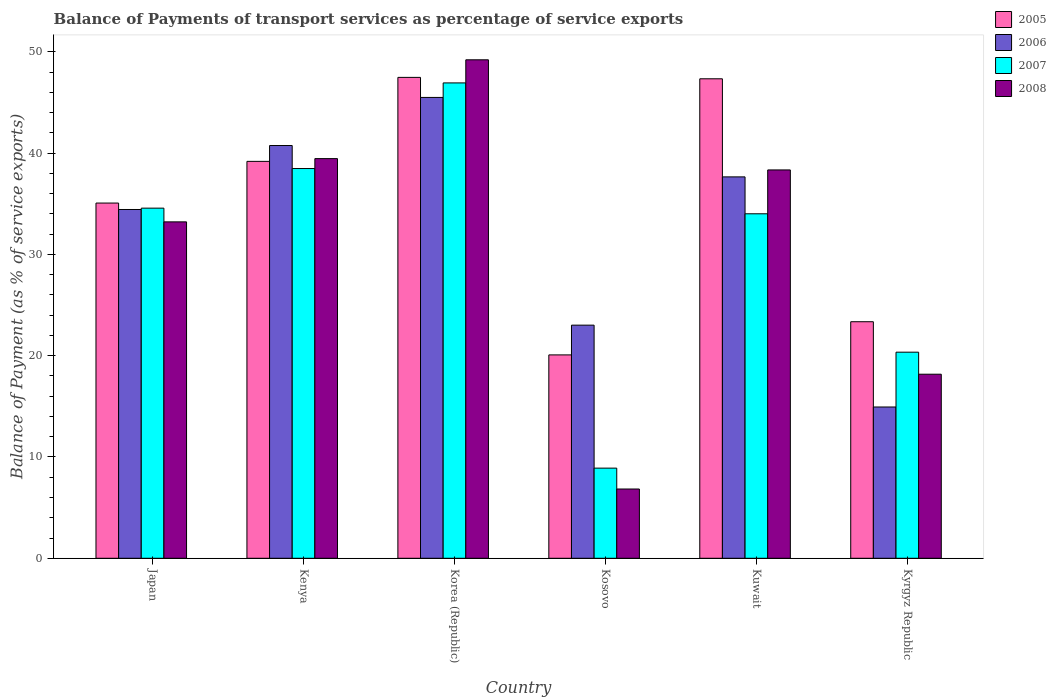How many different coloured bars are there?
Offer a very short reply. 4. How many groups of bars are there?
Offer a terse response. 6. How many bars are there on the 5th tick from the left?
Your answer should be very brief. 4. What is the label of the 3rd group of bars from the left?
Make the answer very short. Korea (Republic). What is the balance of payments of transport services in 2005 in Kenya?
Provide a short and direct response. 39.18. Across all countries, what is the maximum balance of payments of transport services in 2006?
Provide a short and direct response. 45.49. Across all countries, what is the minimum balance of payments of transport services in 2006?
Your answer should be very brief. 14.93. In which country was the balance of payments of transport services in 2005 maximum?
Provide a succinct answer. Korea (Republic). In which country was the balance of payments of transport services in 2006 minimum?
Make the answer very short. Kyrgyz Republic. What is the total balance of payments of transport services in 2006 in the graph?
Your response must be concise. 196.26. What is the difference between the balance of payments of transport services in 2006 in Kosovo and that in Kuwait?
Ensure brevity in your answer.  -14.64. What is the difference between the balance of payments of transport services in 2005 in Kenya and the balance of payments of transport services in 2008 in Korea (Republic)?
Give a very brief answer. -10.03. What is the average balance of payments of transport services in 2006 per country?
Give a very brief answer. 32.71. What is the difference between the balance of payments of transport services of/in 2008 and balance of payments of transport services of/in 2006 in Kosovo?
Your answer should be compact. -16.18. In how many countries, is the balance of payments of transport services in 2006 greater than 8 %?
Your response must be concise. 6. What is the ratio of the balance of payments of transport services in 2005 in Kenya to that in Kyrgyz Republic?
Keep it short and to the point. 1.68. Is the balance of payments of transport services in 2006 in Korea (Republic) less than that in Kosovo?
Keep it short and to the point. No. Is the difference between the balance of payments of transport services in 2008 in Kenya and Kyrgyz Republic greater than the difference between the balance of payments of transport services in 2006 in Kenya and Kyrgyz Republic?
Your answer should be very brief. No. What is the difference between the highest and the second highest balance of payments of transport services in 2005?
Your answer should be compact. -8.15. What is the difference between the highest and the lowest balance of payments of transport services in 2005?
Offer a terse response. 27.4. Is the sum of the balance of payments of transport services in 2005 in Japan and Korea (Republic) greater than the maximum balance of payments of transport services in 2008 across all countries?
Give a very brief answer. Yes. What does the 3rd bar from the left in Japan represents?
Your answer should be compact. 2007. Is it the case that in every country, the sum of the balance of payments of transport services in 2006 and balance of payments of transport services in 2008 is greater than the balance of payments of transport services in 2007?
Your answer should be compact. Yes. Are all the bars in the graph horizontal?
Keep it short and to the point. No. What is the difference between two consecutive major ticks on the Y-axis?
Provide a succinct answer. 10. Are the values on the major ticks of Y-axis written in scientific E-notation?
Ensure brevity in your answer.  No. Does the graph contain grids?
Provide a succinct answer. No. What is the title of the graph?
Offer a very short reply. Balance of Payments of transport services as percentage of service exports. What is the label or title of the Y-axis?
Offer a terse response. Balance of Payment (as % of service exports). What is the Balance of Payment (as % of service exports) of 2005 in Japan?
Provide a succinct answer. 35.06. What is the Balance of Payment (as % of service exports) of 2006 in Japan?
Provide a succinct answer. 34.43. What is the Balance of Payment (as % of service exports) of 2007 in Japan?
Offer a terse response. 34.56. What is the Balance of Payment (as % of service exports) in 2008 in Japan?
Your answer should be compact. 33.21. What is the Balance of Payment (as % of service exports) of 2005 in Kenya?
Your response must be concise. 39.18. What is the Balance of Payment (as % of service exports) of 2006 in Kenya?
Your response must be concise. 40.74. What is the Balance of Payment (as % of service exports) of 2007 in Kenya?
Offer a very short reply. 38.47. What is the Balance of Payment (as % of service exports) of 2008 in Kenya?
Give a very brief answer. 39.45. What is the Balance of Payment (as % of service exports) of 2005 in Korea (Republic)?
Provide a succinct answer. 47.47. What is the Balance of Payment (as % of service exports) of 2006 in Korea (Republic)?
Your answer should be very brief. 45.49. What is the Balance of Payment (as % of service exports) in 2007 in Korea (Republic)?
Provide a short and direct response. 46.92. What is the Balance of Payment (as % of service exports) of 2008 in Korea (Republic)?
Provide a succinct answer. 49.21. What is the Balance of Payment (as % of service exports) in 2005 in Kosovo?
Make the answer very short. 20.08. What is the Balance of Payment (as % of service exports) in 2006 in Kosovo?
Your answer should be very brief. 23.01. What is the Balance of Payment (as % of service exports) in 2007 in Kosovo?
Your answer should be very brief. 8.9. What is the Balance of Payment (as % of service exports) in 2008 in Kosovo?
Your answer should be very brief. 6.84. What is the Balance of Payment (as % of service exports) in 2005 in Kuwait?
Provide a short and direct response. 47.33. What is the Balance of Payment (as % of service exports) of 2006 in Kuwait?
Offer a terse response. 37.65. What is the Balance of Payment (as % of service exports) in 2007 in Kuwait?
Your response must be concise. 34.01. What is the Balance of Payment (as % of service exports) in 2008 in Kuwait?
Provide a succinct answer. 38.33. What is the Balance of Payment (as % of service exports) of 2005 in Kyrgyz Republic?
Provide a short and direct response. 23.35. What is the Balance of Payment (as % of service exports) in 2006 in Kyrgyz Republic?
Your answer should be very brief. 14.93. What is the Balance of Payment (as % of service exports) in 2007 in Kyrgyz Republic?
Your answer should be very brief. 20.34. What is the Balance of Payment (as % of service exports) in 2008 in Kyrgyz Republic?
Your answer should be compact. 18.17. Across all countries, what is the maximum Balance of Payment (as % of service exports) of 2005?
Your response must be concise. 47.47. Across all countries, what is the maximum Balance of Payment (as % of service exports) of 2006?
Offer a very short reply. 45.49. Across all countries, what is the maximum Balance of Payment (as % of service exports) of 2007?
Your answer should be very brief. 46.92. Across all countries, what is the maximum Balance of Payment (as % of service exports) in 2008?
Your response must be concise. 49.21. Across all countries, what is the minimum Balance of Payment (as % of service exports) of 2005?
Provide a short and direct response. 20.08. Across all countries, what is the minimum Balance of Payment (as % of service exports) of 2006?
Your response must be concise. 14.93. Across all countries, what is the minimum Balance of Payment (as % of service exports) in 2007?
Offer a terse response. 8.9. Across all countries, what is the minimum Balance of Payment (as % of service exports) of 2008?
Ensure brevity in your answer.  6.84. What is the total Balance of Payment (as % of service exports) of 2005 in the graph?
Make the answer very short. 212.47. What is the total Balance of Payment (as % of service exports) of 2006 in the graph?
Ensure brevity in your answer.  196.26. What is the total Balance of Payment (as % of service exports) of 2007 in the graph?
Ensure brevity in your answer.  183.21. What is the total Balance of Payment (as % of service exports) of 2008 in the graph?
Ensure brevity in your answer.  185.21. What is the difference between the Balance of Payment (as % of service exports) in 2005 in Japan and that in Kenya?
Ensure brevity in your answer.  -4.12. What is the difference between the Balance of Payment (as % of service exports) in 2006 in Japan and that in Kenya?
Keep it short and to the point. -6.31. What is the difference between the Balance of Payment (as % of service exports) of 2007 in Japan and that in Kenya?
Your response must be concise. -3.91. What is the difference between the Balance of Payment (as % of service exports) of 2008 in Japan and that in Kenya?
Offer a terse response. -6.24. What is the difference between the Balance of Payment (as % of service exports) of 2005 in Japan and that in Korea (Republic)?
Keep it short and to the point. -12.41. What is the difference between the Balance of Payment (as % of service exports) of 2006 in Japan and that in Korea (Republic)?
Make the answer very short. -11.06. What is the difference between the Balance of Payment (as % of service exports) of 2007 in Japan and that in Korea (Republic)?
Give a very brief answer. -12.36. What is the difference between the Balance of Payment (as % of service exports) of 2008 in Japan and that in Korea (Republic)?
Your answer should be very brief. -16. What is the difference between the Balance of Payment (as % of service exports) of 2005 in Japan and that in Kosovo?
Offer a terse response. 14.99. What is the difference between the Balance of Payment (as % of service exports) in 2006 in Japan and that in Kosovo?
Offer a terse response. 11.42. What is the difference between the Balance of Payment (as % of service exports) of 2007 in Japan and that in Kosovo?
Offer a terse response. 25.66. What is the difference between the Balance of Payment (as % of service exports) of 2008 in Japan and that in Kosovo?
Give a very brief answer. 26.37. What is the difference between the Balance of Payment (as % of service exports) in 2005 in Japan and that in Kuwait?
Your answer should be compact. -12.27. What is the difference between the Balance of Payment (as % of service exports) in 2006 in Japan and that in Kuwait?
Offer a terse response. -3.22. What is the difference between the Balance of Payment (as % of service exports) in 2007 in Japan and that in Kuwait?
Ensure brevity in your answer.  0.56. What is the difference between the Balance of Payment (as % of service exports) of 2008 in Japan and that in Kuwait?
Offer a terse response. -5.13. What is the difference between the Balance of Payment (as % of service exports) in 2005 in Japan and that in Kyrgyz Republic?
Your answer should be very brief. 11.71. What is the difference between the Balance of Payment (as % of service exports) in 2006 in Japan and that in Kyrgyz Republic?
Keep it short and to the point. 19.5. What is the difference between the Balance of Payment (as % of service exports) in 2007 in Japan and that in Kyrgyz Republic?
Give a very brief answer. 14.22. What is the difference between the Balance of Payment (as % of service exports) in 2008 in Japan and that in Kyrgyz Republic?
Your answer should be very brief. 15.04. What is the difference between the Balance of Payment (as % of service exports) of 2005 in Kenya and that in Korea (Republic)?
Your response must be concise. -8.29. What is the difference between the Balance of Payment (as % of service exports) of 2006 in Kenya and that in Korea (Republic)?
Your answer should be very brief. -4.75. What is the difference between the Balance of Payment (as % of service exports) in 2007 in Kenya and that in Korea (Republic)?
Your answer should be compact. -8.45. What is the difference between the Balance of Payment (as % of service exports) of 2008 in Kenya and that in Korea (Republic)?
Keep it short and to the point. -9.75. What is the difference between the Balance of Payment (as % of service exports) of 2005 in Kenya and that in Kosovo?
Keep it short and to the point. 19.1. What is the difference between the Balance of Payment (as % of service exports) of 2006 in Kenya and that in Kosovo?
Offer a very short reply. 17.73. What is the difference between the Balance of Payment (as % of service exports) in 2007 in Kenya and that in Kosovo?
Provide a short and direct response. 29.57. What is the difference between the Balance of Payment (as % of service exports) of 2008 in Kenya and that in Kosovo?
Provide a short and direct response. 32.62. What is the difference between the Balance of Payment (as % of service exports) in 2005 in Kenya and that in Kuwait?
Keep it short and to the point. -8.15. What is the difference between the Balance of Payment (as % of service exports) of 2006 in Kenya and that in Kuwait?
Keep it short and to the point. 3.1. What is the difference between the Balance of Payment (as % of service exports) in 2007 in Kenya and that in Kuwait?
Your answer should be very brief. 4.47. What is the difference between the Balance of Payment (as % of service exports) in 2008 in Kenya and that in Kuwait?
Make the answer very short. 1.12. What is the difference between the Balance of Payment (as % of service exports) of 2005 in Kenya and that in Kyrgyz Republic?
Provide a succinct answer. 15.83. What is the difference between the Balance of Payment (as % of service exports) of 2006 in Kenya and that in Kyrgyz Republic?
Provide a succinct answer. 25.81. What is the difference between the Balance of Payment (as % of service exports) of 2007 in Kenya and that in Kyrgyz Republic?
Offer a very short reply. 18.13. What is the difference between the Balance of Payment (as % of service exports) in 2008 in Kenya and that in Kyrgyz Republic?
Keep it short and to the point. 21.28. What is the difference between the Balance of Payment (as % of service exports) in 2005 in Korea (Republic) and that in Kosovo?
Your answer should be compact. 27.4. What is the difference between the Balance of Payment (as % of service exports) of 2006 in Korea (Republic) and that in Kosovo?
Your answer should be very brief. 22.48. What is the difference between the Balance of Payment (as % of service exports) in 2007 in Korea (Republic) and that in Kosovo?
Your answer should be very brief. 38.03. What is the difference between the Balance of Payment (as % of service exports) of 2008 in Korea (Republic) and that in Kosovo?
Offer a terse response. 42.37. What is the difference between the Balance of Payment (as % of service exports) in 2005 in Korea (Republic) and that in Kuwait?
Provide a succinct answer. 0.14. What is the difference between the Balance of Payment (as % of service exports) of 2006 in Korea (Republic) and that in Kuwait?
Your answer should be very brief. 7.84. What is the difference between the Balance of Payment (as % of service exports) in 2007 in Korea (Republic) and that in Kuwait?
Your answer should be compact. 12.92. What is the difference between the Balance of Payment (as % of service exports) of 2008 in Korea (Republic) and that in Kuwait?
Your response must be concise. 10.87. What is the difference between the Balance of Payment (as % of service exports) in 2005 in Korea (Republic) and that in Kyrgyz Republic?
Make the answer very short. 24.12. What is the difference between the Balance of Payment (as % of service exports) in 2006 in Korea (Republic) and that in Kyrgyz Republic?
Offer a very short reply. 30.56. What is the difference between the Balance of Payment (as % of service exports) of 2007 in Korea (Republic) and that in Kyrgyz Republic?
Your response must be concise. 26.58. What is the difference between the Balance of Payment (as % of service exports) of 2008 in Korea (Republic) and that in Kyrgyz Republic?
Your answer should be compact. 31.04. What is the difference between the Balance of Payment (as % of service exports) of 2005 in Kosovo and that in Kuwait?
Give a very brief answer. -27.26. What is the difference between the Balance of Payment (as % of service exports) of 2006 in Kosovo and that in Kuwait?
Keep it short and to the point. -14.64. What is the difference between the Balance of Payment (as % of service exports) in 2007 in Kosovo and that in Kuwait?
Offer a terse response. -25.11. What is the difference between the Balance of Payment (as % of service exports) in 2008 in Kosovo and that in Kuwait?
Keep it short and to the point. -31.5. What is the difference between the Balance of Payment (as % of service exports) of 2005 in Kosovo and that in Kyrgyz Republic?
Your answer should be compact. -3.27. What is the difference between the Balance of Payment (as % of service exports) of 2006 in Kosovo and that in Kyrgyz Republic?
Provide a short and direct response. 8.08. What is the difference between the Balance of Payment (as % of service exports) in 2007 in Kosovo and that in Kyrgyz Republic?
Provide a short and direct response. -11.45. What is the difference between the Balance of Payment (as % of service exports) of 2008 in Kosovo and that in Kyrgyz Republic?
Make the answer very short. -11.33. What is the difference between the Balance of Payment (as % of service exports) in 2005 in Kuwait and that in Kyrgyz Republic?
Provide a succinct answer. 23.98. What is the difference between the Balance of Payment (as % of service exports) in 2006 in Kuwait and that in Kyrgyz Republic?
Your response must be concise. 22.72. What is the difference between the Balance of Payment (as % of service exports) of 2007 in Kuwait and that in Kyrgyz Republic?
Provide a short and direct response. 13.66. What is the difference between the Balance of Payment (as % of service exports) in 2008 in Kuwait and that in Kyrgyz Republic?
Give a very brief answer. 20.17. What is the difference between the Balance of Payment (as % of service exports) of 2005 in Japan and the Balance of Payment (as % of service exports) of 2006 in Kenya?
Ensure brevity in your answer.  -5.68. What is the difference between the Balance of Payment (as % of service exports) in 2005 in Japan and the Balance of Payment (as % of service exports) in 2007 in Kenya?
Give a very brief answer. -3.41. What is the difference between the Balance of Payment (as % of service exports) of 2005 in Japan and the Balance of Payment (as % of service exports) of 2008 in Kenya?
Keep it short and to the point. -4.39. What is the difference between the Balance of Payment (as % of service exports) in 2006 in Japan and the Balance of Payment (as % of service exports) in 2007 in Kenya?
Your response must be concise. -4.04. What is the difference between the Balance of Payment (as % of service exports) of 2006 in Japan and the Balance of Payment (as % of service exports) of 2008 in Kenya?
Your response must be concise. -5.02. What is the difference between the Balance of Payment (as % of service exports) of 2007 in Japan and the Balance of Payment (as % of service exports) of 2008 in Kenya?
Your answer should be very brief. -4.89. What is the difference between the Balance of Payment (as % of service exports) of 2005 in Japan and the Balance of Payment (as % of service exports) of 2006 in Korea (Republic)?
Offer a terse response. -10.43. What is the difference between the Balance of Payment (as % of service exports) of 2005 in Japan and the Balance of Payment (as % of service exports) of 2007 in Korea (Republic)?
Your answer should be compact. -11.86. What is the difference between the Balance of Payment (as % of service exports) of 2005 in Japan and the Balance of Payment (as % of service exports) of 2008 in Korea (Republic)?
Give a very brief answer. -14.14. What is the difference between the Balance of Payment (as % of service exports) in 2006 in Japan and the Balance of Payment (as % of service exports) in 2007 in Korea (Republic)?
Your answer should be compact. -12.49. What is the difference between the Balance of Payment (as % of service exports) in 2006 in Japan and the Balance of Payment (as % of service exports) in 2008 in Korea (Republic)?
Offer a very short reply. -14.78. What is the difference between the Balance of Payment (as % of service exports) in 2007 in Japan and the Balance of Payment (as % of service exports) in 2008 in Korea (Republic)?
Your response must be concise. -14.64. What is the difference between the Balance of Payment (as % of service exports) of 2005 in Japan and the Balance of Payment (as % of service exports) of 2006 in Kosovo?
Ensure brevity in your answer.  12.05. What is the difference between the Balance of Payment (as % of service exports) in 2005 in Japan and the Balance of Payment (as % of service exports) in 2007 in Kosovo?
Keep it short and to the point. 26.17. What is the difference between the Balance of Payment (as % of service exports) of 2005 in Japan and the Balance of Payment (as % of service exports) of 2008 in Kosovo?
Your response must be concise. 28.23. What is the difference between the Balance of Payment (as % of service exports) of 2006 in Japan and the Balance of Payment (as % of service exports) of 2007 in Kosovo?
Make the answer very short. 25.53. What is the difference between the Balance of Payment (as % of service exports) of 2006 in Japan and the Balance of Payment (as % of service exports) of 2008 in Kosovo?
Make the answer very short. 27.59. What is the difference between the Balance of Payment (as % of service exports) of 2007 in Japan and the Balance of Payment (as % of service exports) of 2008 in Kosovo?
Offer a very short reply. 27.73. What is the difference between the Balance of Payment (as % of service exports) of 2005 in Japan and the Balance of Payment (as % of service exports) of 2006 in Kuwait?
Make the answer very short. -2.58. What is the difference between the Balance of Payment (as % of service exports) in 2005 in Japan and the Balance of Payment (as % of service exports) in 2007 in Kuwait?
Make the answer very short. 1.06. What is the difference between the Balance of Payment (as % of service exports) of 2005 in Japan and the Balance of Payment (as % of service exports) of 2008 in Kuwait?
Ensure brevity in your answer.  -3.27. What is the difference between the Balance of Payment (as % of service exports) in 2006 in Japan and the Balance of Payment (as % of service exports) in 2007 in Kuwait?
Make the answer very short. 0.42. What is the difference between the Balance of Payment (as % of service exports) in 2006 in Japan and the Balance of Payment (as % of service exports) in 2008 in Kuwait?
Offer a terse response. -3.9. What is the difference between the Balance of Payment (as % of service exports) in 2007 in Japan and the Balance of Payment (as % of service exports) in 2008 in Kuwait?
Provide a short and direct response. -3.77. What is the difference between the Balance of Payment (as % of service exports) in 2005 in Japan and the Balance of Payment (as % of service exports) in 2006 in Kyrgyz Republic?
Give a very brief answer. 20.13. What is the difference between the Balance of Payment (as % of service exports) of 2005 in Japan and the Balance of Payment (as % of service exports) of 2007 in Kyrgyz Republic?
Keep it short and to the point. 14.72. What is the difference between the Balance of Payment (as % of service exports) in 2005 in Japan and the Balance of Payment (as % of service exports) in 2008 in Kyrgyz Republic?
Offer a very short reply. 16.9. What is the difference between the Balance of Payment (as % of service exports) in 2006 in Japan and the Balance of Payment (as % of service exports) in 2007 in Kyrgyz Republic?
Make the answer very short. 14.09. What is the difference between the Balance of Payment (as % of service exports) of 2006 in Japan and the Balance of Payment (as % of service exports) of 2008 in Kyrgyz Republic?
Your answer should be very brief. 16.26. What is the difference between the Balance of Payment (as % of service exports) of 2007 in Japan and the Balance of Payment (as % of service exports) of 2008 in Kyrgyz Republic?
Your answer should be compact. 16.39. What is the difference between the Balance of Payment (as % of service exports) in 2005 in Kenya and the Balance of Payment (as % of service exports) in 2006 in Korea (Republic)?
Offer a terse response. -6.31. What is the difference between the Balance of Payment (as % of service exports) in 2005 in Kenya and the Balance of Payment (as % of service exports) in 2007 in Korea (Republic)?
Provide a short and direct response. -7.74. What is the difference between the Balance of Payment (as % of service exports) of 2005 in Kenya and the Balance of Payment (as % of service exports) of 2008 in Korea (Republic)?
Your response must be concise. -10.03. What is the difference between the Balance of Payment (as % of service exports) in 2006 in Kenya and the Balance of Payment (as % of service exports) in 2007 in Korea (Republic)?
Your response must be concise. -6.18. What is the difference between the Balance of Payment (as % of service exports) in 2006 in Kenya and the Balance of Payment (as % of service exports) in 2008 in Korea (Republic)?
Your response must be concise. -8.46. What is the difference between the Balance of Payment (as % of service exports) of 2007 in Kenya and the Balance of Payment (as % of service exports) of 2008 in Korea (Republic)?
Give a very brief answer. -10.73. What is the difference between the Balance of Payment (as % of service exports) of 2005 in Kenya and the Balance of Payment (as % of service exports) of 2006 in Kosovo?
Provide a short and direct response. 16.17. What is the difference between the Balance of Payment (as % of service exports) in 2005 in Kenya and the Balance of Payment (as % of service exports) in 2007 in Kosovo?
Your answer should be compact. 30.28. What is the difference between the Balance of Payment (as % of service exports) in 2005 in Kenya and the Balance of Payment (as % of service exports) in 2008 in Kosovo?
Ensure brevity in your answer.  32.34. What is the difference between the Balance of Payment (as % of service exports) in 2006 in Kenya and the Balance of Payment (as % of service exports) in 2007 in Kosovo?
Keep it short and to the point. 31.85. What is the difference between the Balance of Payment (as % of service exports) in 2006 in Kenya and the Balance of Payment (as % of service exports) in 2008 in Kosovo?
Keep it short and to the point. 33.91. What is the difference between the Balance of Payment (as % of service exports) of 2007 in Kenya and the Balance of Payment (as % of service exports) of 2008 in Kosovo?
Give a very brief answer. 31.63. What is the difference between the Balance of Payment (as % of service exports) of 2005 in Kenya and the Balance of Payment (as % of service exports) of 2006 in Kuwait?
Offer a terse response. 1.53. What is the difference between the Balance of Payment (as % of service exports) in 2005 in Kenya and the Balance of Payment (as % of service exports) in 2007 in Kuwait?
Give a very brief answer. 5.17. What is the difference between the Balance of Payment (as % of service exports) of 2005 in Kenya and the Balance of Payment (as % of service exports) of 2008 in Kuwait?
Make the answer very short. 0.84. What is the difference between the Balance of Payment (as % of service exports) of 2006 in Kenya and the Balance of Payment (as % of service exports) of 2007 in Kuwait?
Your response must be concise. 6.74. What is the difference between the Balance of Payment (as % of service exports) in 2006 in Kenya and the Balance of Payment (as % of service exports) in 2008 in Kuwait?
Give a very brief answer. 2.41. What is the difference between the Balance of Payment (as % of service exports) of 2007 in Kenya and the Balance of Payment (as % of service exports) of 2008 in Kuwait?
Make the answer very short. 0.14. What is the difference between the Balance of Payment (as % of service exports) of 2005 in Kenya and the Balance of Payment (as % of service exports) of 2006 in Kyrgyz Republic?
Ensure brevity in your answer.  24.25. What is the difference between the Balance of Payment (as % of service exports) in 2005 in Kenya and the Balance of Payment (as % of service exports) in 2007 in Kyrgyz Republic?
Provide a succinct answer. 18.84. What is the difference between the Balance of Payment (as % of service exports) of 2005 in Kenya and the Balance of Payment (as % of service exports) of 2008 in Kyrgyz Republic?
Make the answer very short. 21.01. What is the difference between the Balance of Payment (as % of service exports) in 2006 in Kenya and the Balance of Payment (as % of service exports) in 2007 in Kyrgyz Republic?
Make the answer very short. 20.4. What is the difference between the Balance of Payment (as % of service exports) of 2006 in Kenya and the Balance of Payment (as % of service exports) of 2008 in Kyrgyz Republic?
Your answer should be compact. 22.58. What is the difference between the Balance of Payment (as % of service exports) in 2007 in Kenya and the Balance of Payment (as % of service exports) in 2008 in Kyrgyz Republic?
Offer a terse response. 20.3. What is the difference between the Balance of Payment (as % of service exports) in 2005 in Korea (Republic) and the Balance of Payment (as % of service exports) in 2006 in Kosovo?
Give a very brief answer. 24.46. What is the difference between the Balance of Payment (as % of service exports) of 2005 in Korea (Republic) and the Balance of Payment (as % of service exports) of 2007 in Kosovo?
Make the answer very short. 38.57. What is the difference between the Balance of Payment (as % of service exports) of 2005 in Korea (Republic) and the Balance of Payment (as % of service exports) of 2008 in Kosovo?
Offer a very short reply. 40.63. What is the difference between the Balance of Payment (as % of service exports) in 2006 in Korea (Republic) and the Balance of Payment (as % of service exports) in 2007 in Kosovo?
Ensure brevity in your answer.  36.59. What is the difference between the Balance of Payment (as % of service exports) of 2006 in Korea (Republic) and the Balance of Payment (as % of service exports) of 2008 in Kosovo?
Your response must be concise. 38.65. What is the difference between the Balance of Payment (as % of service exports) of 2007 in Korea (Republic) and the Balance of Payment (as % of service exports) of 2008 in Kosovo?
Your answer should be compact. 40.09. What is the difference between the Balance of Payment (as % of service exports) of 2005 in Korea (Republic) and the Balance of Payment (as % of service exports) of 2006 in Kuwait?
Provide a succinct answer. 9.82. What is the difference between the Balance of Payment (as % of service exports) in 2005 in Korea (Republic) and the Balance of Payment (as % of service exports) in 2007 in Kuwait?
Your answer should be compact. 13.47. What is the difference between the Balance of Payment (as % of service exports) of 2005 in Korea (Republic) and the Balance of Payment (as % of service exports) of 2008 in Kuwait?
Offer a terse response. 9.14. What is the difference between the Balance of Payment (as % of service exports) in 2006 in Korea (Republic) and the Balance of Payment (as % of service exports) in 2007 in Kuwait?
Offer a terse response. 11.49. What is the difference between the Balance of Payment (as % of service exports) in 2006 in Korea (Republic) and the Balance of Payment (as % of service exports) in 2008 in Kuwait?
Offer a terse response. 7.16. What is the difference between the Balance of Payment (as % of service exports) in 2007 in Korea (Republic) and the Balance of Payment (as % of service exports) in 2008 in Kuwait?
Your response must be concise. 8.59. What is the difference between the Balance of Payment (as % of service exports) in 2005 in Korea (Republic) and the Balance of Payment (as % of service exports) in 2006 in Kyrgyz Republic?
Provide a short and direct response. 32.54. What is the difference between the Balance of Payment (as % of service exports) in 2005 in Korea (Republic) and the Balance of Payment (as % of service exports) in 2007 in Kyrgyz Republic?
Offer a very short reply. 27.13. What is the difference between the Balance of Payment (as % of service exports) of 2005 in Korea (Republic) and the Balance of Payment (as % of service exports) of 2008 in Kyrgyz Republic?
Offer a very short reply. 29.3. What is the difference between the Balance of Payment (as % of service exports) of 2006 in Korea (Republic) and the Balance of Payment (as % of service exports) of 2007 in Kyrgyz Republic?
Give a very brief answer. 25.15. What is the difference between the Balance of Payment (as % of service exports) in 2006 in Korea (Republic) and the Balance of Payment (as % of service exports) in 2008 in Kyrgyz Republic?
Ensure brevity in your answer.  27.32. What is the difference between the Balance of Payment (as % of service exports) in 2007 in Korea (Republic) and the Balance of Payment (as % of service exports) in 2008 in Kyrgyz Republic?
Ensure brevity in your answer.  28.75. What is the difference between the Balance of Payment (as % of service exports) of 2005 in Kosovo and the Balance of Payment (as % of service exports) of 2006 in Kuwait?
Keep it short and to the point. -17.57. What is the difference between the Balance of Payment (as % of service exports) of 2005 in Kosovo and the Balance of Payment (as % of service exports) of 2007 in Kuwait?
Offer a terse response. -13.93. What is the difference between the Balance of Payment (as % of service exports) in 2005 in Kosovo and the Balance of Payment (as % of service exports) in 2008 in Kuwait?
Ensure brevity in your answer.  -18.26. What is the difference between the Balance of Payment (as % of service exports) in 2006 in Kosovo and the Balance of Payment (as % of service exports) in 2007 in Kuwait?
Give a very brief answer. -10.99. What is the difference between the Balance of Payment (as % of service exports) of 2006 in Kosovo and the Balance of Payment (as % of service exports) of 2008 in Kuwait?
Your answer should be very brief. -15.32. What is the difference between the Balance of Payment (as % of service exports) of 2007 in Kosovo and the Balance of Payment (as % of service exports) of 2008 in Kuwait?
Your answer should be very brief. -29.44. What is the difference between the Balance of Payment (as % of service exports) in 2005 in Kosovo and the Balance of Payment (as % of service exports) in 2006 in Kyrgyz Republic?
Ensure brevity in your answer.  5.14. What is the difference between the Balance of Payment (as % of service exports) of 2005 in Kosovo and the Balance of Payment (as % of service exports) of 2007 in Kyrgyz Republic?
Offer a very short reply. -0.27. What is the difference between the Balance of Payment (as % of service exports) in 2005 in Kosovo and the Balance of Payment (as % of service exports) in 2008 in Kyrgyz Republic?
Give a very brief answer. 1.91. What is the difference between the Balance of Payment (as % of service exports) in 2006 in Kosovo and the Balance of Payment (as % of service exports) in 2007 in Kyrgyz Republic?
Keep it short and to the point. 2.67. What is the difference between the Balance of Payment (as % of service exports) in 2006 in Kosovo and the Balance of Payment (as % of service exports) in 2008 in Kyrgyz Republic?
Provide a succinct answer. 4.84. What is the difference between the Balance of Payment (as % of service exports) of 2007 in Kosovo and the Balance of Payment (as % of service exports) of 2008 in Kyrgyz Republic?
Provide a succinct answer. -9.27. What is the difference between the Balance of Payment (as % of service exports) of 2005 in Kuwait and the Balance of Payment (as % of service exports) of 2006 in Kyrgyz Republic?
Give a very brief answer. 32.4. What is the difference between the Balance of Payment (as % of service exports) of 2005 in Kuwait and the Balance of Payment (as % of service exports) of 2007 in Kyrgyz Republic?
Make the answer very short. 26.99. What is the difference between the Balance of Payment (as % of service exports) in 2005 in Kuwait and the Balance of Payment (as % of service exports) in 2008 in Kyrgyz Republic?
Ensure brevity in your answer.  29.16. What is the difference between the Balance of Payment (as % of service exports) of 2006 in Kuwait and the Balance of Payment (as % of service exports) of 2007 in Kyrgyz Republic?
Your answer should be very brief. 17.3. What is the difference between the Balance of Payment (as % of service exports) of 2006 in Kuwait and the Balance of Payment (as % of service exports) of 2008 in Kyrgyz Republic?
Provide a succinct answer. 19.48. What is the difference between the Balance of Payment (as % of service exports) in 2007 in Kuwait and the Balance of Payment (as % of service exports) in 2008 in Kyrgyz Republic?
Give a very brief answer. 15.84. What is the average Balance of Payment (as % of service exports) of 2005 per country?
Your response must be concise. 35.41. What is the average Balance of Payment (as % of service exports) of 2006 per country?
Give a very brief answer. 32.71. What is the average Balance of Payment (as % of service exports) of 2007 per country?
Make the answer very short. 30.53. What is the average Balance of Payment (as % of service exports) of 2008 per country?
Your answer should be compact. 30.87. What is the difference between the Balance of Payment (as % of service exports) of 2005 and Balance of Payment (as % of service exports) of 2006 in Japan?
Your answer should be compact. 0.63. What is the difference between the Balance of Payment (as % of service exports) of 2005 and Balance of Payment (as % of service exports) of 2007 in Japan?
Make the answer very short. 0.5. What is the difference between the Balance of Payment (as % of service exports) in 2005 and Balance of Payment (as % of service exports) in 2008 in Japan?
Offer a very short reply. 1.86. What is the difference between the Balance of Payment (as % of service exports) in 2006 and Balance of Payment (as % of service exports) in 2007 in Japan?
Your answer should be compact. -0.13. What is the difference between the Balance of Payment (as % of service exports) of 2006 and Balance of Payment (as % of service exports) of 2008 in Japan?
Make the answer very short. 1.22. What is the difference between the Balance of Payment (as % of service exports) in 2007 and Balance of Payment (as % of service exports) in 2008 in Japan?
Your answer should be very brief. 1.36. What is the difference between the Balance of Payment (as % of service exports) in 2005 and Balance of Payment (as % of service exports) in 2006 in Kenya?
Provide a short and direct response. -1.56. What is the difference between the Balance of Payment (as % of service exports) in 2005 and Balance of Payment (as % of service exports) in 2007 in Kenya?
Offer a very short reply. 0.71. What is the difference between the Balance of Payment (as % of service exports) in 2005 and Balance of Payment (as % of service exports) in 2008 in Kenya?
Offer a terse response. -0.27. What is the difference between the Balance of Payment (as % of service exports) in 2006 and Balance of Payment (as % of service exports) in 2007 in Kenya?
Offer a very short reply. 2.27. What is the difference between the Balance of Payment (as % of service exports) of 2006 and Balance of Payment (as % of service exports) of 2008 in Kenya?
Provide a short and direct response. 1.29. What is the difference between the Balance of Payment (as % of service exports) in 2007 and Balance of Payment (as % of service exports) in 2008 in Kenya?
Make the answer very short. -0.98. What is the difference between the Balance of Payment (as % of service exports) of 2005 and Balance of Payment (as % of service exports) of 2006 in Korea (Republic)?
Offer a very short reply. 1.98. What is the difference between the Balance of Payment (as % of service exports) in 2005 and Balance of Payment (as % of service exports) in 2007 in Korea (Republic)?
Give a very brief answer. 0.55. What is the difference between the Balance of Payment (as % of service exports) in 2005 and Balance of Payment (as % of service exports) in 2008 in Korea (Republic)?
Provide a succinct answer. -1.74. What is the difference between the Balance of Payment (as % of service exports) of 2006 and Balance of Payment (as % of service exports) of 2007 in Korea (Republic)?
Make the answer very short. -1.43. What is the difference between the Balance of Payment (as % of service exports) of 2006 and Balance of Payment (as % of service exports) of 2008 in Korea (Republic)?
Provide a short and direct response. -3.71. What is the difference between the Balance of Payment (as % of service exports) of 2007 and Balance of Payment (as % of service exports) of 2008 in Korea (Republic)?
Ensure brevity in your answer.  -2.28. What is the difference between the Balance of Payment (as % of service exports) of 2005 and Balance of Payment (as % of service exports) of 2006 in Kosovo?
Make the answer very short. -2.94. What is the difference between the Balance of Payment (as % of service exports) of 2005 and Balance of Payment (as % of service exports) of 2007 in Kosovo?
Your answer should be compact. 11.18. What is the difference between the Balance of Payment (as % of service exports) of 2005 and Balance of Payment (as % of service exports) of 2008 in Kosovo?
Give a very brief answer. 13.24. What is the difference between the Balance of Payment (as % of service exports) of 2006 and Balance of Payment (as % of service exports) of 2007 in Kosovo?
Your answer should be very brief. 14.11. What is the difference between the Balance of Payment (as % of service exports) in 2006 and Balance of Payment (as % of service exports) in 2008 in Kosovo?
Offer a very short reply. 16.18. What is the difference between the Balance of Payment (as % of service exports) in 2007 and Balance of Payment (as % of service exports) in 2008 in Kosovo?
Offer a very short reply. 2.06. What is the difference between the Balance of Payment (as % of service exports) in 2005 and Balance of Payment (as % of service exports) in 2006 in Kuwait?
Make the answer very short. 9.68. What is the difference between the Balance of Payment (as % of service exports) of 2005 and Balance of Payment (as % of service exports) of 2007 in Kuwait?
Give a very brief answer. 13.33. What is the difference between the Balance of Payment (as % of service exports) of 2005 and Balance of Payment (as % of service exports) of 2008 in Kuwait?
Provide a short and direct response. 9. What is the difference between the Balance of Payment (as % of service exports) of 2006 and Balance of Payment (as % of service exports) of 2007 in Kuwait?
Make the answer very short. 3.64. What is the difference between the Balance of Payment (as % of service exports) in 2006 and Balance of Payment (as % of service exports) in 2008 in Kuwait?
Make the answer very short. -0.69. What is the difference between the Balance of Payment (as % of service exports) in 2007 and Balance of Payment (as % of service exports) in 2008 in Kuwait?
Your response must be concise. -4.33. What is the difference between the Balance of Payment (as % of service exports) of 2005 and Balance of Payment (as % of service exports) of 2006 in Kyrgyz Republic?
Your answer should be very brief. 8.42. What is the difference between the Balance of Payment (as % of service exports) in 2005 and Balance of Payment (as % of service exports) in 2007 in Kyrgyz Republic?
Provide a succinct answer. 3. What is the difference between the Balance of Payment (as % of service exports) in 2005 and Balance of Payment (as % of service exports) in 2008 in Kyrgyz Republic?
Make the answer very short. 5.18. What is the difference between the Balance of Payment (as % of service exports) of 2006 and Balance of Payment (as % of service exports) of 2007 in Kyrgyz Republic?
Provide a succinct answer. -5.41. What is the difference between the Balance of Payment (as % of service exports) of 2006 and Balance of Payment (as % of service exports) of 2008 in Kyrgyz Republic?
Provide a succinct answer. -3.24. What is the difference between the Balance of Payment (as % of service exports) in 2007 and Balance of Payment (as % of service exports) in 2008 in Kyrgyz Republic?
Ensure brevity in your answer.  2.18. What is the ratio of the Balance of Payment (as % of service exports) in 2005 in Japan to that in Kenya?
Provide a short and direct response. 0.9. What is the ratio of the Balance of Payment (as % of service exports) of 2006 in Japan to that in Kenya?
Ensure brevity in your answer.  0.84. What is the ratio of the Balance of Payment (as % of service exports) of 2007 in Japan to that in Kenya?
Your answer should be very brief. 0.9. What is the ratio of the Balance of Payment (as % of service exports) of 2008 in Japan to that in Kenya?
Your answer should be very brief. 0.84. What is the ratio of the Balance of Payment (as % of service exports) in 2005 in Japan to that in Korea (Republic)?
Provide a succinct answer. 0.74. What is the ratio of the Balance of Payment (as % of service exports) in 2006 in Japan to that in Korea (Republic)?
Keep it short and to the point. 0.76. What is the ratio of the Balance of Payment (as % of service exports) in 2007 in Japan to that in Korea (Republic)?
Your answer should be compact. 0.74. What is the ratio of the Balance of Payment (as % of service exports) in 2008 in Japan to that in Korea (Republic)?
Offer a terse response. 0.67. What is the ratio of the Balance of Payment (as % of service exports) in 2005 in Japan to that in Kosovo?
Keep it short and to the point. 1.75. What is the ratio of the Balance of Payment (as % of service exports) in 2006 in Japan to that in Kosovo?
Your answer should be compact. 1.5. What is the ratio of the Balance of Payment (as % of service exports) of 2007 in Japan to that in Kosovo?
Offer a terse response. 3.88. What is the ratio of the Balance of Payment (as % of service exports) of 2008 in Japan to that in Kosovo?
Provide a short and direct response. 4.86. What is the ratio of the Balance of Payment (as % of service exports) in 2005 in Japan to that in Kuwait?
Your answer should be very brief. 0.74. What is the ratio of the Balance of Payment (as % of service exports) of 2006 in Japan to that in Kuwait?
Your response must be concise. 0.91. What is the ratio of the Balance of Payment (as % of service exports) of 2007 in Japan to that in Kuwait?
Your answer should be very brief. 1.02. What is the ratio of the Balance of Payment (as % of service exports) in 2008 in Japan to that in Kuwait?
Provide a short and direct response. 0.87. What is the ratio of the Balance of Payment (as % of service exports) of 2005 in Japan to that in Kyrgyz Republic?
Provide a succinct answer. 1.5. What is the ratio of the Balance of Payment (as % of service exports) of 2006 in Japan to that in Kyrgyz Republic?
Provide a succinct answer. 2.31. What is the ratio of the Balance of Payment (as % of service exports) in 2007 in Japan to that in Kyrgyz Republic?
Your response must be concise. 1.7. What is the ratio of the Balance of Payment (as % of service exports) of 2008 in Japan to that in Kyrgyz Republic?
Provide a succinct answer. 1.83. What is the ratio of the Balance of Payment (as % of service exports) of 2005 in Kenya to that in Korea (Republic)?
Your answer should be very brief. 0.83. What is the ratio of the Balance of Payment (as % of service exports) of 2006 in Kenya to that in Korea (Republic)?
Offer a very short reply. 0.9. What is the ratio of the Balance of Payment (as % of service exports) in 2007 in Kenya to that in Korea (Republic)?
Offer a very short reply. 0.82. What is the ratio of the Balance of Payment (as % of service exports) in 2008 in Kenya to that in Korea (Republic)?
Keep it short and to the point. 0.8. What is the ratio of the Balance of Payment (as % of service exports) in 2005 in Kenya to that in Kosovo?
Keep it short and to the point. 1.95. What is the ratio of the Balance of Payment (as % of service exports) of 2006 in Kenya to that in Kosovo?
Your answer should be compact. 1.77. What is the ratio of the Balance of Payment (as % of service exports) of 2007 in Kenya to that in Kosovo?
Keep it short and to the point. 4.32. What is the ratio of the Balance of Payment (as % of service exports) of 2008 in Kenya to that in Kosovo?
Offer a very short reply. 5.77. What is the ratio of the Balance of Payment (as % of service exports) of 2005 in Kenya to that in Kuwait?
Make the answer very short. 0.83. What is the ratio of the Balance of Payment (as % of service exports) of 2006 in Kenya to that in Kuwait?
Provide a short and direct response. 1.08. What is the ratio of the Balance of Payment (as % of service exports) of 2007 in Kenya to that in Kuwait?
Keep it short and to the point. 1.13. What is the ratio of the Balance of Payment (as % of service exports) in 2008 in Kenya to that in Kuwait?
Ensure brevity in your answer.  1.03. What is the ratio of the Balance of Payment (as % of service exports) of 2005 in Kenya to that in Kyrgyz Republic?
Ensure brevity in your answer.  1.68. What is the ratio of the Balance of Payment (as % of service exports) of 2006 in Kenya to that in Kyrgyz Republic?
Provide a short and direct response. 2.73. What is the ratio of the Balance of Payment (as % of service exports) of 2007 in Kenya to that in Kyrgyz Republic?
Your answer should be compact. 1.89. What is the ratio of the Balance of Payment (as % of service exports) of 2008 in Kenya to that in Kyrgyz Republic?
Make the answer very short. 2.17. What is the ratio of the Balance of Payment (as % of service exports) in 2005 in Korea (Republic) to that in Kosovo?
Offer a very short reply. 2.36. What is the ratio of the Balance of Payment (as % of service exports) of 2006 in Korea (Republic) to that in Kosovo?
Offer a very short reply. 1.98. What is the ratio of the Balance of Payment (as % of service exports) in 2007 in Korea (Republic) to that in Kosovo?
Your answer should be very brief. 5.27. What is the ratio of the Balance of Payment (as % of service exports) of 2008 in Korea (Republic) to that in Kosovo?
Ensure brevity in your answer.  7.2. What is the ratio of the Balance of Payment (as % of service exports) of 2005 in Korea (Republic) to that in Kuwait?
Your answer should be very brief. 1. What is the ratio of the Balance of Payment (as % of service exports) of 2006 in Korea (Republic) to that in Kuwait?
Offer a very short reply. 1.21. What is the ratio of the Balance of Payment (as % of service exports) of 2007 in Korea (Republic) to that in Kuwait?
Your answer should be compact. 1.38. What is the ratio of the Balance of Payment (as % of service exports) in 2008 in Korea (Republic) to that in Kuwait?
Provide a short and direct response. 1.28. What is the ratio of the Balance of Payment (as % of service exports) in 2005 in Korea (Republic) to that in Kyrgyz Republic?
Provide a short and direct response. 2.03. What is the ratio of the Balance of Payment (as % of service exports) in 2006 in Korea (Republic) to that in Kyrgyz Republic?
Ensure brevity in your answer.  3.05. What is the ratio of the Balance of Payment (as % of service exports) of 2007 in Korea (Republic) to that in Kyrgyz Republic?
Your answer should be very brief. 2.31. What is the ratio of the Balance of Payment (as % of service exports) in 2008 in Korea (Republic) to that in Kyrgyz Republic?
Give a very brief answer. 2.71. What is the ratio of the Balance of Payment (as % of service exports) of 2005 in Kosovo to that in Kuwait?
Ensure brevity in your answer.  0.42. What is the ratio of the Balance of Payment (as % of service exports) in 2006 in Kosovo to that in Kuwait?
Your answer should be very brief. 0.61. What is the ratio of the Balance of Payment (as % of service exports) of 2007 in Kosovo to that in Kuwait?
Offer a terse response. 0.26. What is the ratio of the Balance of Payment (as % of service exports) in 2008 in Kosovo to that in Kuwait?
Make the answer very short. 0.18. What is the ratio of the Balance of Payment (as % of service exports) of 2005 in Kosovo to that in Kyrgyz Republic?
Your answer should be compact. 0.86. What is the ratio of the Balance of Payment (as % of service exports) in 2006 in Kosovo to that in Kyrgyz Republic?
Offer a very short reply. 1.54. What is the ratio of the Balance of Payment (as % of service exports) of 2007 in Kosovo to that in Kyrgyz Republic?
Give a very brief answer. 0.44. What is the ratio of the Balance of Payment (as % of service exports) of 2008 in Kosovo to that in Kyrgyz Republic?
Your response must be concise. 0.38. What is the ratio of the Balance of Payment (as % of service exports) in 2005 in Kuwait to that in Kyrgyz Republic?
Keep it short and to the point. 2.03. What is the ratio of the Balance of Payment (as % of service exports) in 2006 in Kuwait to that in Kyrgyz Republic?
Provide a short and direct response. 2.52. What is the ratio of the Balance of Payment (as % of service exports) of 2007 in Kuwait to that in Kyrgyz Republic?
Your answer should be very brief. 1.67. What is the ratio of the Balance of Payment (as % of service exports) in 2008 in Kuwait to that in Kyrgyz Republic?
Your answer should be very brief. 2.11. What is the difference between the highest and the second highest Balance of Payment (as % of service exports) of 2005?
Offer a terse response. 0.14. What is the difference between the highest and the second highest Balance of Payment (as % of service exports) of 2006?
Your answer should be compact. 4.75. What is the difference between the highest and the second highest Balance of Payment (as % of service exports) in 2007?
Offer a terse response. 8.45. What is the difference between the highest and the second highest Balance of Payment (as % of service exports) in 2008?
Make the answer very short. 9.75. What is the difference between the highest and the lowest Balance of Payment (as % of service exports) of 2005?
Offer a very short reply. 27.4. What is the difference between the highest and the lowest Balance of Payment (as % of service exports) in 2006?
Ensure brevity in your answer.  30.56. What is the difference between the highest and the lowest Balance of Payment (as % of service exports) of 2007?
Give a very brief answer. 38.03. What is the difference between the highest and the lowest Balance of Payment (as % of service exports) of 2008?
Your response must be concise. 42.37. 